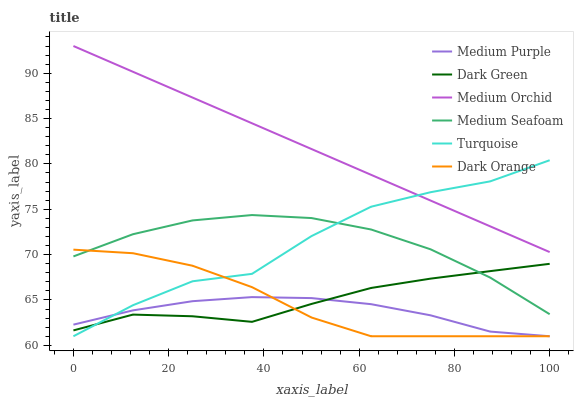Does Medium Purple have the minimum area under the curve?
Answer yes or no. Yes. Does Medium Orchid have the maximum area under the curve?
Answer yes or no. Yes. Does Turquoise have the minimum area under the curve?
Answer yes or no. No. Does Turquoise have the maximum area under the curve?
Answer yes or no. No. Is Medium Orchid the smoothest?
Answer yes or no. Yes. Is Turquoise the roughest?
Answer yes or no. Yes. Is Turquoise the smoothest?
Answer yes or no. No. Is Medium Orchid the roughest?
Answer yes or no. No. Does Medium Orchid have the lowest value?
Answer yes or no. No. Does Turquoise have the highest value?
Answer yes or no. No. Is Medium Purple less than Medium Orchid?
Answer yes or no. Yes. Is Medium Orchid greater than Dark Green?
Answer yes or no. Yes. Does Medium Purple intersect Medium Orchid?
Answer yes or no. No. 